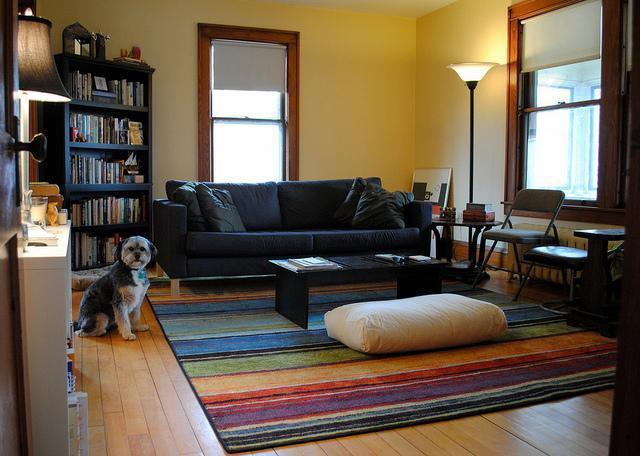What sound does the animal make?
Select the accurate response from the four choices given to answer the question.
Options: Neigh, woof, moo, meow. Woof. 